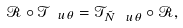<formula> <loc_0><loc_0><loc_500><loc_500>\mathcal { R } \circ \mathcal { T } _ { \ u { \theta } } = \mathcal { T } _ { \tilde { N } \ u { \theta } } \circ \mathcal { R } ,</formula> 